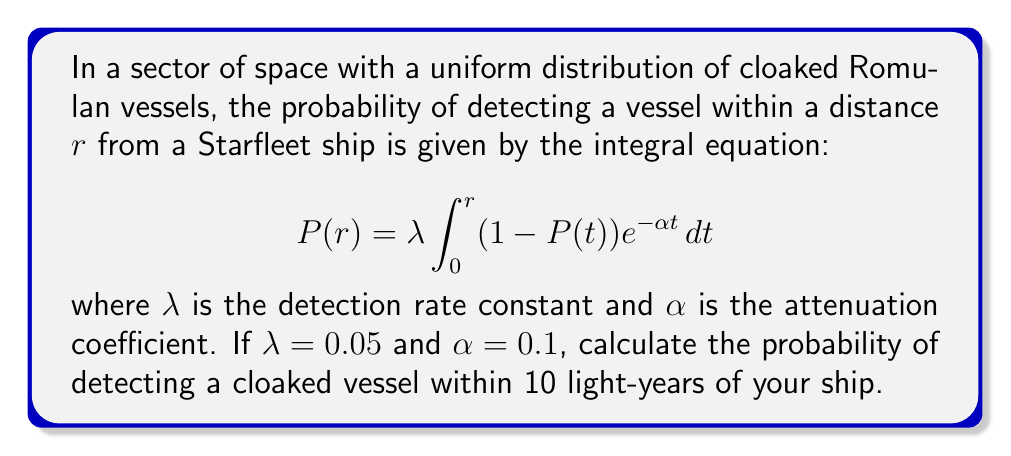Provide a solution to this math problem. To solve this integral equation, we'll follow these steps:

1) First, we need to differentiate both sides of the equation with respect to $r$:

   $$\frac{dP}{dr} = \lambda (1 - P(r)) e^{-\alpha r}$$

2) This gives us a first-order linear differential equation. We can rearrange it:

   $$\frac{dP}{dr} + \lambda e^{-\alpha r} P = \lambda e^{-\alpha r}$$

3) This is in the form of $\frac{dy}{dx} + P(x)y = Q(x)$, where $P(x) = \lambda e^{-\alpha r}$ and $Q(x) = \lambda e^{-\alpha r}$.

4) The integrating factor is $\mu(r) = e^{\int P(r) dr} = e^{\int \lambda e^{-\alpha r} dr} = e^{-\frac{\lambda}{\alpha}e^{-\alpha r}}$.

5) Multiplying both sides by $\mu(r)$:

   $$e^{-\frac{\lambda}{\alpha}e^{-\alpha r}} \frac{dP}{dr} + \lambda e^{-\alpha r} e^{-\frac{\lambda}{\alpha}e^{-\alpha r}} P = \lambda e^{-\alpha r} e^{-\frac{\lambda}{\alpha}e^{-\alpha r}}$$

6) This can be written as:

   $$\frac{d}{dr}(P e^{-\frac{\lambda}{\alpha}e^{-\alpha r}}) = \lambda e^{-\alpha r} e^{-\frac{\lambda}{\alpha}e^{-\alpha r}}$$

7) Integrating both sides:

   $$P e^{-\frac{\lambda}{\alpha}e^{-\alpha r}} = -\frac{\lambda}{\alpha} e^{-\frac{\lambda}{\alpha}e^{-\alpha r}} + C$$

8) Solving for $P$:

   $$P = 1 - e^{\frac{\lambda}{\alpha}e^{-\alpha r} - \frac{\lambda}{\alpha}}$$

9) Using the initial condition $P(0) = 0$, we can find $C$:

   $$0 = 1 - e^{\frac{\lambda}{\alpha} - \frac{\lambda}{\alpha}} = 1 - 1 = 0$$

   So our solution satisfies the initial condition.

10) Now, we can plug in the values $\lambda = 0.05$, $\alpha = 0.1$, and $r = 10$:

    $$P(10) = 1 - e^{\frac{0.05}{0.1}e^{-0.1 \cdot 10} - \frac{0.05}{0.1}}$$

11) Simplifying:

    $$P(10) = 1 - e^{0.5e^{-1} - 0.5} \approx 0.3935$$

Therefore, the probability of detecting a cloaked vessel within 10 light-years is approximately 0.3935 or 39.35%.
Answer: $0.3935$ or $39.35\%$ 